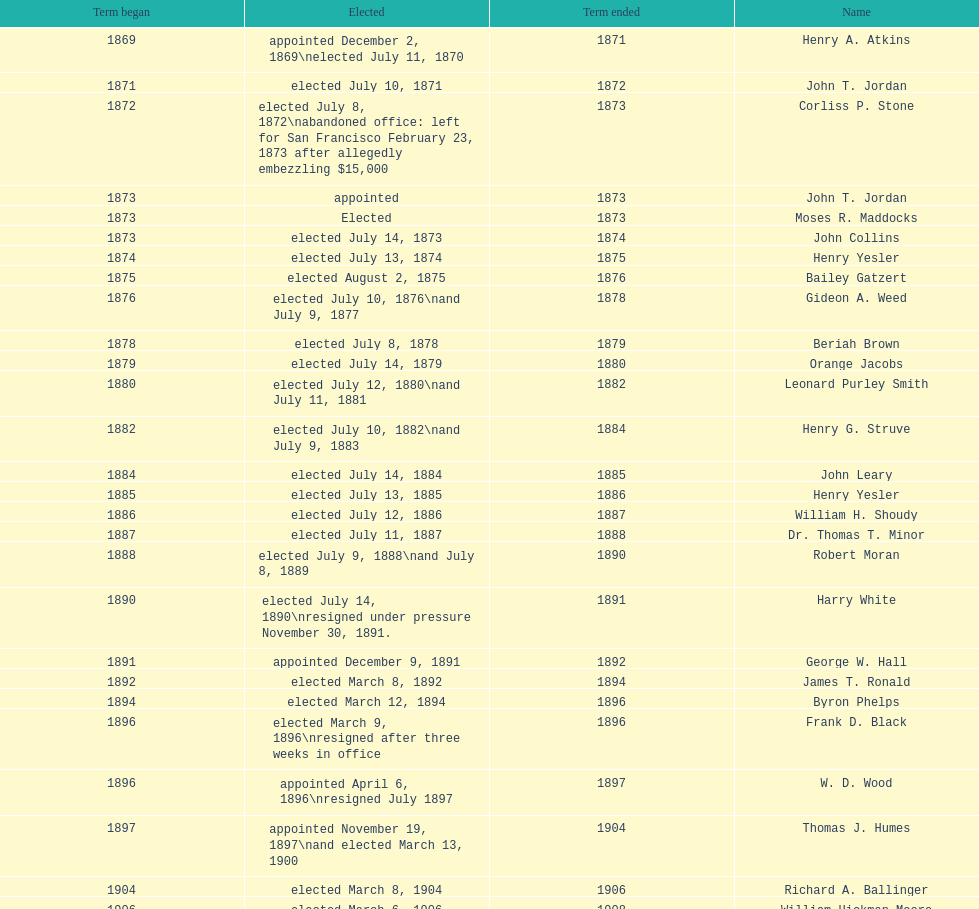What is the number of mayors with the first name of john? 6. 